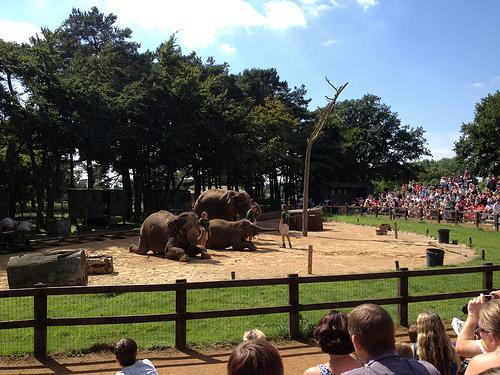Identify the fence in the image and discuss its purpose. There is a fence surrounding the elephant enclosure meant to keep the elephants and spectators safe. Discuss the positioning of the people around the elephants. People are standing in front, beside, and all around the enclosure, close to the three elephants, in various positions and interacting with them. Give a brief overview of the audience's engagement with the scene. A crowd of people, some in green and blue shirts, are watching the elephants perform and interacting closely with them. Identify the objects located above the elephant enclosure. Above the enclosure, there is a bright blue sky with a few clouds, and some tall thin tree trunks with no leaves. Count the elephants in the image, and describe their posture and actions. There are three elephants; one is kneeling, the second is lying down, and the third is standing with its trunk extended forward. Describe the overall sentiment of the image by assessing the elements found within the scene. The image has a positive vibe as it depicts a crowd of people enjoying and interacting with the elephants performing tricks in a vibrant, outdoor environment. What are the three largest animals in the scene and what are they doing? Three elephants are performing tricks in the enclosure, with one kneeling, one lying down, and the third standing. How many people are wearing green shirts and what are they doing? Three people are wearing green shirts, standing close to the elephants and watching them perform. Describe any notable objects in the enclosure and their features. The enclosure has a large wood log, a green trash can, and a black bin, all set on the grass and fenced area. Briefly describe the weather and the environment in the image. The image shows a bright blue sky with a few clouds, many leafy green trees, and a brown dirt area where the elephants are performing. Write a poetic description of the scene involving the elephants and their audience. Under a radiant blue sky, the mighty elephants command the stage, their enchanting feats weaving a spell upon their captivated viewers. What is a notable feature of the elephant in the middle? Its trunk is extended forward. Could you point out the red ball that the middle elephant is playing with? No, it's not mentioned in the image. Based on the image, who is watching the elephants? A crowd of people Write an image caption mentioning the color of the sky and the scene taking place. Bright blue sky at the zoo where three elephants are performing tricks for an audience. What is the color of the trash can in the enclosure? Green What are the three persons wearing green shirts doing in relation to the elephants? Standing close to the elephants and watching them perform What is happening with the elephants in the enclosure? They are performing tricks. What object can be found across the grass in the enclosure? A fence Choose the correct description of the trees in the image: a) bare trees with no leaves, b) leafy green trees, c) palm trees b) leafy green trees What color is the sky in the image? Bright blue Identify the main event taking place in this image. Elephants performing tricks for an audience in a zoo. Based on the image, describe the hair of the woman within the audience. Wavy blonde and light brown hair Describe the position of the woman with wavy blonde and light brown hair. She is on the right side of the audience. From the information given, deduce the general type of activity taking place in the image. A zoo presentation or show featuring elephants Which elements of the image can be interpreted as barriers or separators? Fences What is the predominant element of the ground where the elephants perform? Brown dirt Explain the role of humans in this particular scene involving elephants. People are watching the elephants perform tricks and some are standing close to them. Can you locate the umbrella held by the woman with long hair? There is no mention of an umbrella or any object related to a woman with long hair besides the woman herself. This instruction is misleading as it implies the presence of a non-existent object. Is the tallest elephant standing, kneeling or lying down? Standing Describe the scene involving the elephants and their audience in a creative manner. A mesmerizing spectacle unfolds on a sunny day as three magnificent elephants display their incredible abilities, captivating their audience. 